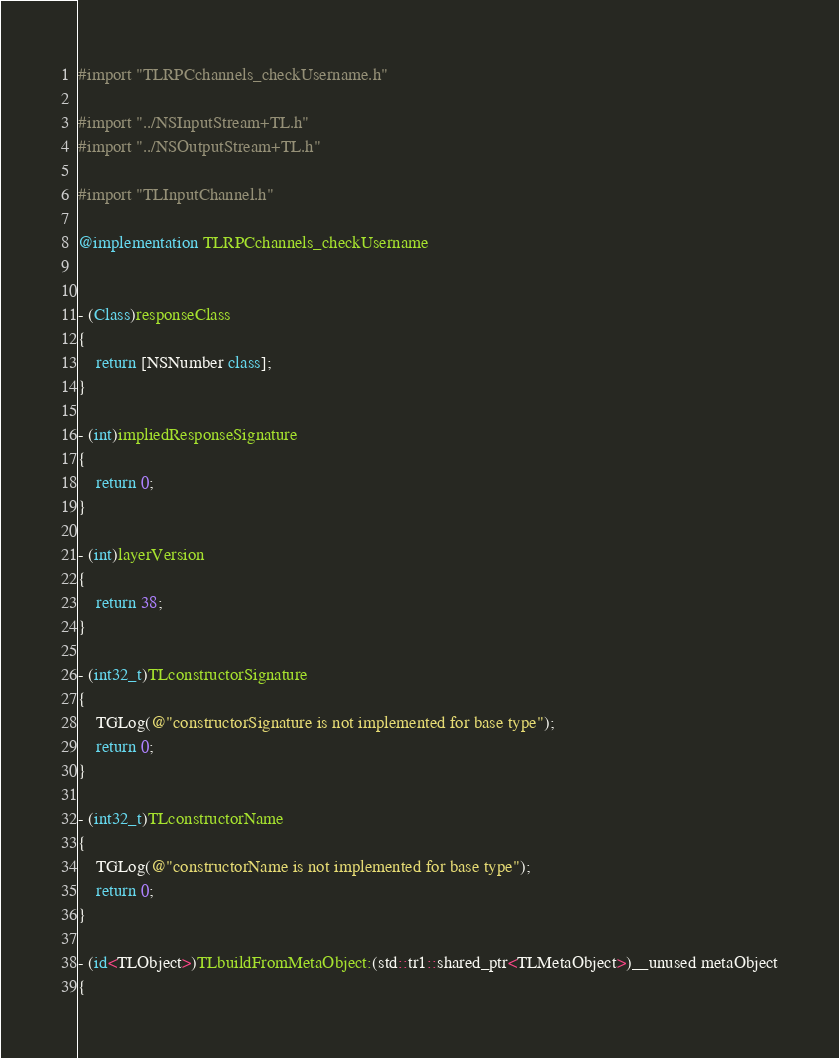Convert code to text. <code><loc_0><loc_0><loc_500><loc_500><_ObjectiveC_>#import "TLRPCchannels_checkUsername.h"

#import "../NSInputStream+TL.h"
#import "../NSOutputStream+TL.h"

#import "TLInputChannel.h"

@implementation TLRPCchannels_checkUsername


- (Class)responseClass
{
    return [NSNumber class];
}

- (int)impliedResponseSignature
{
    return 0;
}

- (int)layerVersion
{
    return 38;
}

- (int32_t)TLconstructorSignature
{
    TGLog(@"constructorSignature is not implemented for base type");
    return 0;
}

- (int32_t)TLconstructorName
{
    TGLog(@"constructorName is not implemented for base type");
    return 0;
}

- (id<TLObject>)TLbuildFromMetaObject:(std::tr1::shared_ptr<TLMetaObject>)__unused metaObject
{</code> 